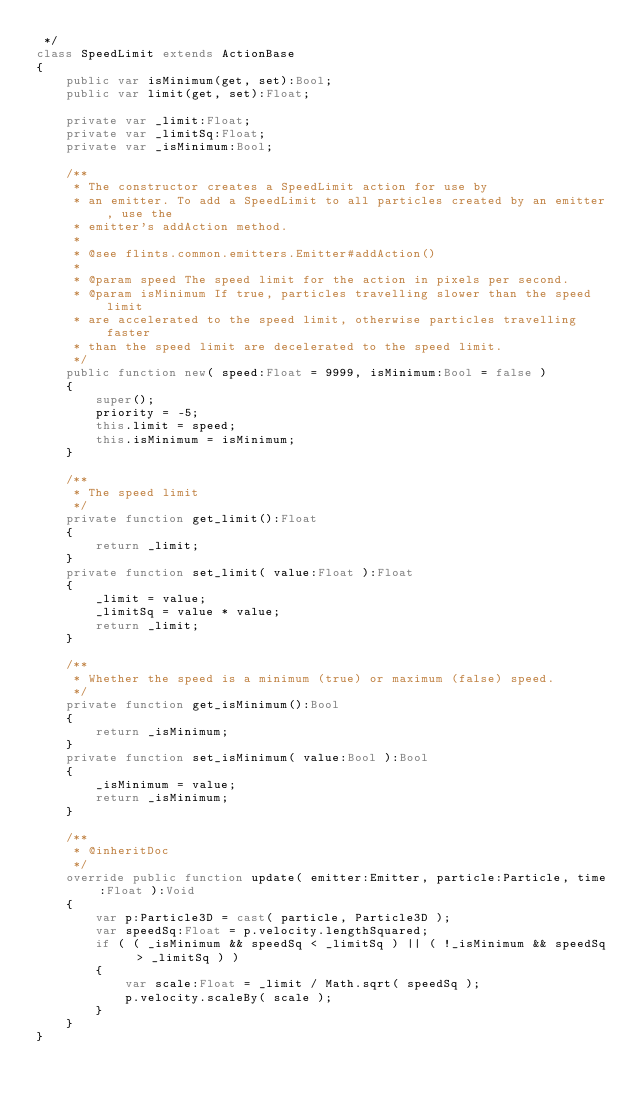Convert code to text. <code><loc_0><loc_0><loc_500><loc_500><_Haxe_> */
class SpeedLimit extends ActionBase
{
	public var isMinimum(get, set):Bool;
	public var limit(get, set):Float;
	
	private var _limit:Float;
	private var _limitSq:Float;
	private var _isMinimum:Bool;
	
	/**
	 * The constructor creates a SpeedLimit action for use by 
	 * an emitter. To add a SpeedLimit to all particles created by an emitter, use the
	 * emitter's addAction method.
	 * 
	 * @see flints.common.emitters.Emitter#addAction()
	 * 
	 * @param speed The speed limit for the action in pixels per second.
	 * @param isMinimum If true, particles travelling slower than the speed limit
	 * are accelerated to the speed limit, otherwise particles travelling faster
	 * than the speed limit are decelerated to the speed limit.
	 */
	public function new( speed:Float = 9999, isMinimum:Bool = false )
	{
		super();
		priority = -5;
		this.limit = speed;
		this.isMinimum = isMinimum;
	}
	
	/**
	 * The speed limit
	 */
	private function get_limit():Float
	{
		return _limit;
	}
	private function set_limit( value:Float ):Float
	{
		_limit = value;
		_limitSq = value * value;
		return _limit;
	}
	
	/**
	 * Whether the speed is a minimum (true) or maximum (false) speed.
	 */
	private function get_isMinimum():Bool
	{
		return _isMinimum;
	}
	private function set_isMinimum( value:Bool ):Bool
	{
		_isMinimum = value;
		return _isMinimum;
	}

	/**
	 * @inheritDoc
	 */
	override public function update( emitter:Emitter, particle:Particle, time:Float ):Void
	{
		var p:Particle3D = cast( particle, Particle3D );
		var speedSq:Float = p.velocity.lengthSquared;
		if ( ( _isMinimum && speedSq < _limitSq ) || ( !_isMinimum && speedSq > _limitSq ) )
		{
			var scale:Float = _limit / Math.sqrt( speedSq );
			p.velocity.scaleBy( scale );
		}
	}
}
</code> 